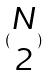Convert formula to latex. <formula><loc_0><loc_0><loc_500><loc_500>( \begin{matrix} N \\ 2 \end{matrix} )</formula> 